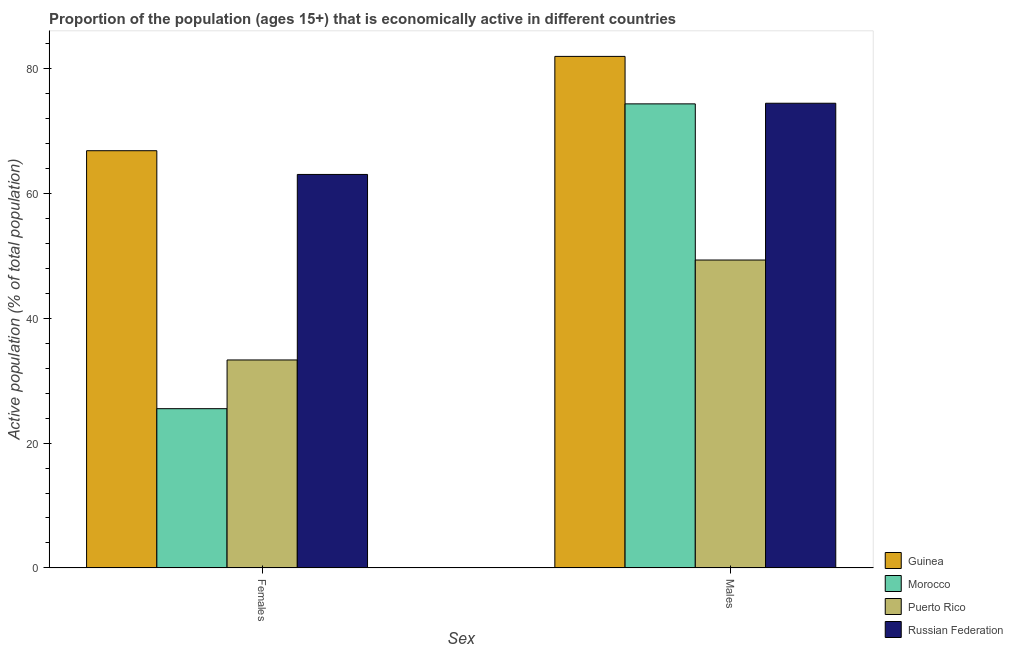How many different coloured bars are there?
Give a very brief answer. 4. How many groups of bars are there?
Your response must be concise. 2. What is the label of the 2nd group of bars from the left?
Offer a terse response. Males. What is the percentage of economically active male population in Russian Federation?
Offer a terse response. 74.4. Across all countries, what is the maximum percentage of economically active male population?
Give a very brief answer. 81.9. Across all countries, what is the minimum percentage of economically active female population?
Your answer should be compact. 25.5. In which country was the percentage of economically active male population maximum?
Give a very brief answer. Guinea. In which country was the percentage of economically active female population minimum?
Make the answer very short. Morocco. What is the total percentage of economically active male population in the graph?
Ensure brevity in your answer.  279.9. What is the difference between the percentage of economically active female population in Guinea and that in Puerto Rico?
Give a very brief answer. 33.5. What is the difference between the percentage of economically active male population in Russian Federation and the percentage of economically active female population in Morocco?
Ensure brevity in your answer.  48.9. What is the average percentage of economically active female population per country?
Give a very brief answer. 47.15. What is the difference between the percentage of economically active female population and percentage of economically active male population in Morocco?
Keep it short and to the point. -48.8. What is the ratio of the percentage of economically active female population in Puerto Rico to that in Russian Federation?
Keep it short and to the point. 0.53. Is the percentage of economically active female population in Morocco less than that in Russian Federation?
Ensure brevity in your answer.  Yes. What does the 4th bar from the left in Males represents?
Ensure brevity in your answer.  Russian Federation. What does the 3rd bar from the right in Males represents?
Your response must be concise. Morocco. Are all the bars in the graph horizontal?
Provide a succinct answer. No. What is the difference between two consecutive major ticks on the Y-axis?
Offer a very short reply. 20. Are the values on the major ticks of Y-axis written in scientific E-notation?
Ensure brevity in your answer.  No. Does the graph contain any zero values?
Make the answer very short. No. How many legend labels are there?
Offer a very short reply. 4. What is the title of the graph?
Ensure brevity in your answer.  Proportion of the population (ages 15+) that is economically active in different countries. What is the label or title of the X-axis?
Your answer should be compact. Sex. What is the label or title of the Y-axis?
Offer a terse response. Active population (% of total population). What is the Active population (% of total population) of Guinea in Females?
Give a very brief answer. 66.8. What is the Active population (% of total population) of Morocco in Females?
Make the answer very short. 25.5. What is the Active population (% of total population) of Puerto Rico in Females?
Your answer should be very brief. 33.3. What is the Active population (% of total population) of Russian Federation in Females?
Make the answer very short. 63. What is the Active population (% of total population) of Guinea in Males?
Offer a terse response. 81.9. What is the Active population (% of total population) in Morocco in Males?
Your answer should be compact. 74.3. What is the Active population (% of total population) in Puerto Rico in Males?
Make the answer very short. 49.3. What is the Active population (% of total population) in Russian Federation in Males?
Keep it short and to the point. 74.4. Across all Sex, what is the maximum Active population (% of total population) of Guinea?
Provide a succinct answer. 81.9. Across all Sex, what is the maximum Active population (% of total population) of Morocco?
Provide a short and direct response. 74.3. Across all Sex, what is the maximum Active population (% of total population) of Puerto Rico?
Ensure brevity in your answer.  49.3. Across all Sex, what is the maximum Active population (% of total population) in Russian Federation?
Offer a very short reply. 74.4. Across all Sex, what is the minimum Active population (% of total population) in Guinea?
Provide a succinct answer. 66.8. Across all Sex, what is the minimum Active population (% of total population) of Puerto Rico?
Your response must be concise. 33.3. Across all Sex, what is the minimum Active population (% of total population) of Russian Federation?
Your response must be concise. 63. What is the total Active population (% of total population) of Guinea in the graph?
Give a very brief answer. 148.7. What is the total Active population (% of total population) in Morocco in the graph?
Ensure brevity in your answer.  99.8. What is the total Active population (% of total population) in Puerto Rico in the graph?
Your response must be concise. 82.6. What is the total Active population (% of total population) in Russian Federation in the graph?
Your answer should be very brief. 137.4. What is the difference between the Active population (% of total population) of Guinea in Females and that in Males?
Offer a very short reply. -15.1. What is the difference between the Active population (% of total population) in Morocco in Females and that in Males?
Give a very brief answer. -48.8. What is the difference between the Active population (% of total population) in Guinea in Females and the Active population (% of total population) in Puerto Rico in Males?
Provide a short and direct response. 17.5. What is the difference between the Active population (% of total population) of Guinea in Females and the Active population (% of total population) of Russian Federation in Males?
Provide a short and direct response. -7.6. What is the difference between the Active population (% of total population) of Morocco in Females and the Active population (% of total population) of Puerto Rico in Males?
Keep it short and to the point. -23.8. What is the difference between the Active population (% of total population) of Morocco in Females and the Active population (% of total population) of Russian Federation in Males?
Offer a very short reply. -48.9. What is the difference between the Active population (% of total population) in Puerto Rico in Females and the Active population (% of total population) in Russian Federation in Males?
Provide a succinct answer. -41.1. What is the average Active population (% of total population) of Guinea per Sex?
Give a very brief answer. 74.35. What is the average Active population (% of total population) in Morocco per Sex?
Make the answer very short. 49.9. What is the average Active population (% of total population) in Puerto Rico per Sex?
Keep it short and to the point. 41.3. What is the average Active population (% of total population) of Russian Federation per Sex?
Keep it short and to the point. 68.7. What is the difference between the Active population (% of total population) of Guinea and Active population (% of total population) of Morocco in Females?
Your response must be concise. 41.3. What is the difference between the Active population (% of total population) of Guinea and Active population (% of total population) of Puerto Rico in Females?
Offer a terse response. 33.5. What is the difference between the Active population (% of total population) of Morocco and Active population (% of total population) of Puerto Rico in Females?
Give a very brief answer. -7.8. What is the difference between the Active population (% of total population) of Morocco and Active population (% of total population) of Russian Federation in Females?
Your response must be concise. -37.5. What is the difference between the Active population (% of total population) of Puerto Rico and Active population (% of total population) of Russian Federation in Females?
Offer a terse response. -29.7. What is the difference between the Active population (% of total population) in Guinea and Active population (% of total population) in Morocco in Males?
Provide a short and direct response. 7.6. What is the difference between the Active population (% of total population) in Guinea and Active population (% of total population) in Puerto Rico in Males?
Offer a very short reply. 32.6. What is the difference between the Active population (% of total population) of Morocco and Active population (% of total population) of Puerto Rico in Males?
Make the answer very short. 25. What is the difference between the Active population (% of total population) of Morocco and Active population (% of total population) of Russian Federation in Males?
Provide a short and direct response. -0.1. What is the difference between the Active population (% of total population) in Puerto Rico and Active population (% of total population) in Russian Federation in Males?
Offer a very short reply. -25.1. What is the ratio of the Active population (% of total population) of Guinea in Females to that in Males?
Your answer should be compact. 0.82. What is the ratio of the Active population (% of total population) of Morocco in Females to that in Males?
Make the answer very short. 0.34. What is the ratio of the Active population (% of total population) of Puerto Rico in Females to that in Males?
Make the answer very short. 0.68. What is the ratio of the Active population (% of total population) of Russian Federation in Females to that in Males?
Ensure brevity in your answer.  0.85. What is the difference between the highest and the second highest Active population (% of total population) of Guinea?
Your answer should be very brief. 15.1. What is the difference between the highest and the second highest Active population (% of total population) in Morocco?
Offer a terse response. 48.8. What is the difference between the highest and the second highest Active population (% of total population) of Puerto Rico?
Offer a very short reply. 16. What is the difference between the highest and the second highest Active population (% of total population) in Russian Federation?
Ensure brevity in your answer.  11.4. What is the difference between the highest and the lowest Active population (% of total population) in Morocco?
Your answer should be compact. 48.8. What is the difference between the highest and the lowest Active population (% of total population) of Puerto Rico?
Give a very brief answer. 16. 